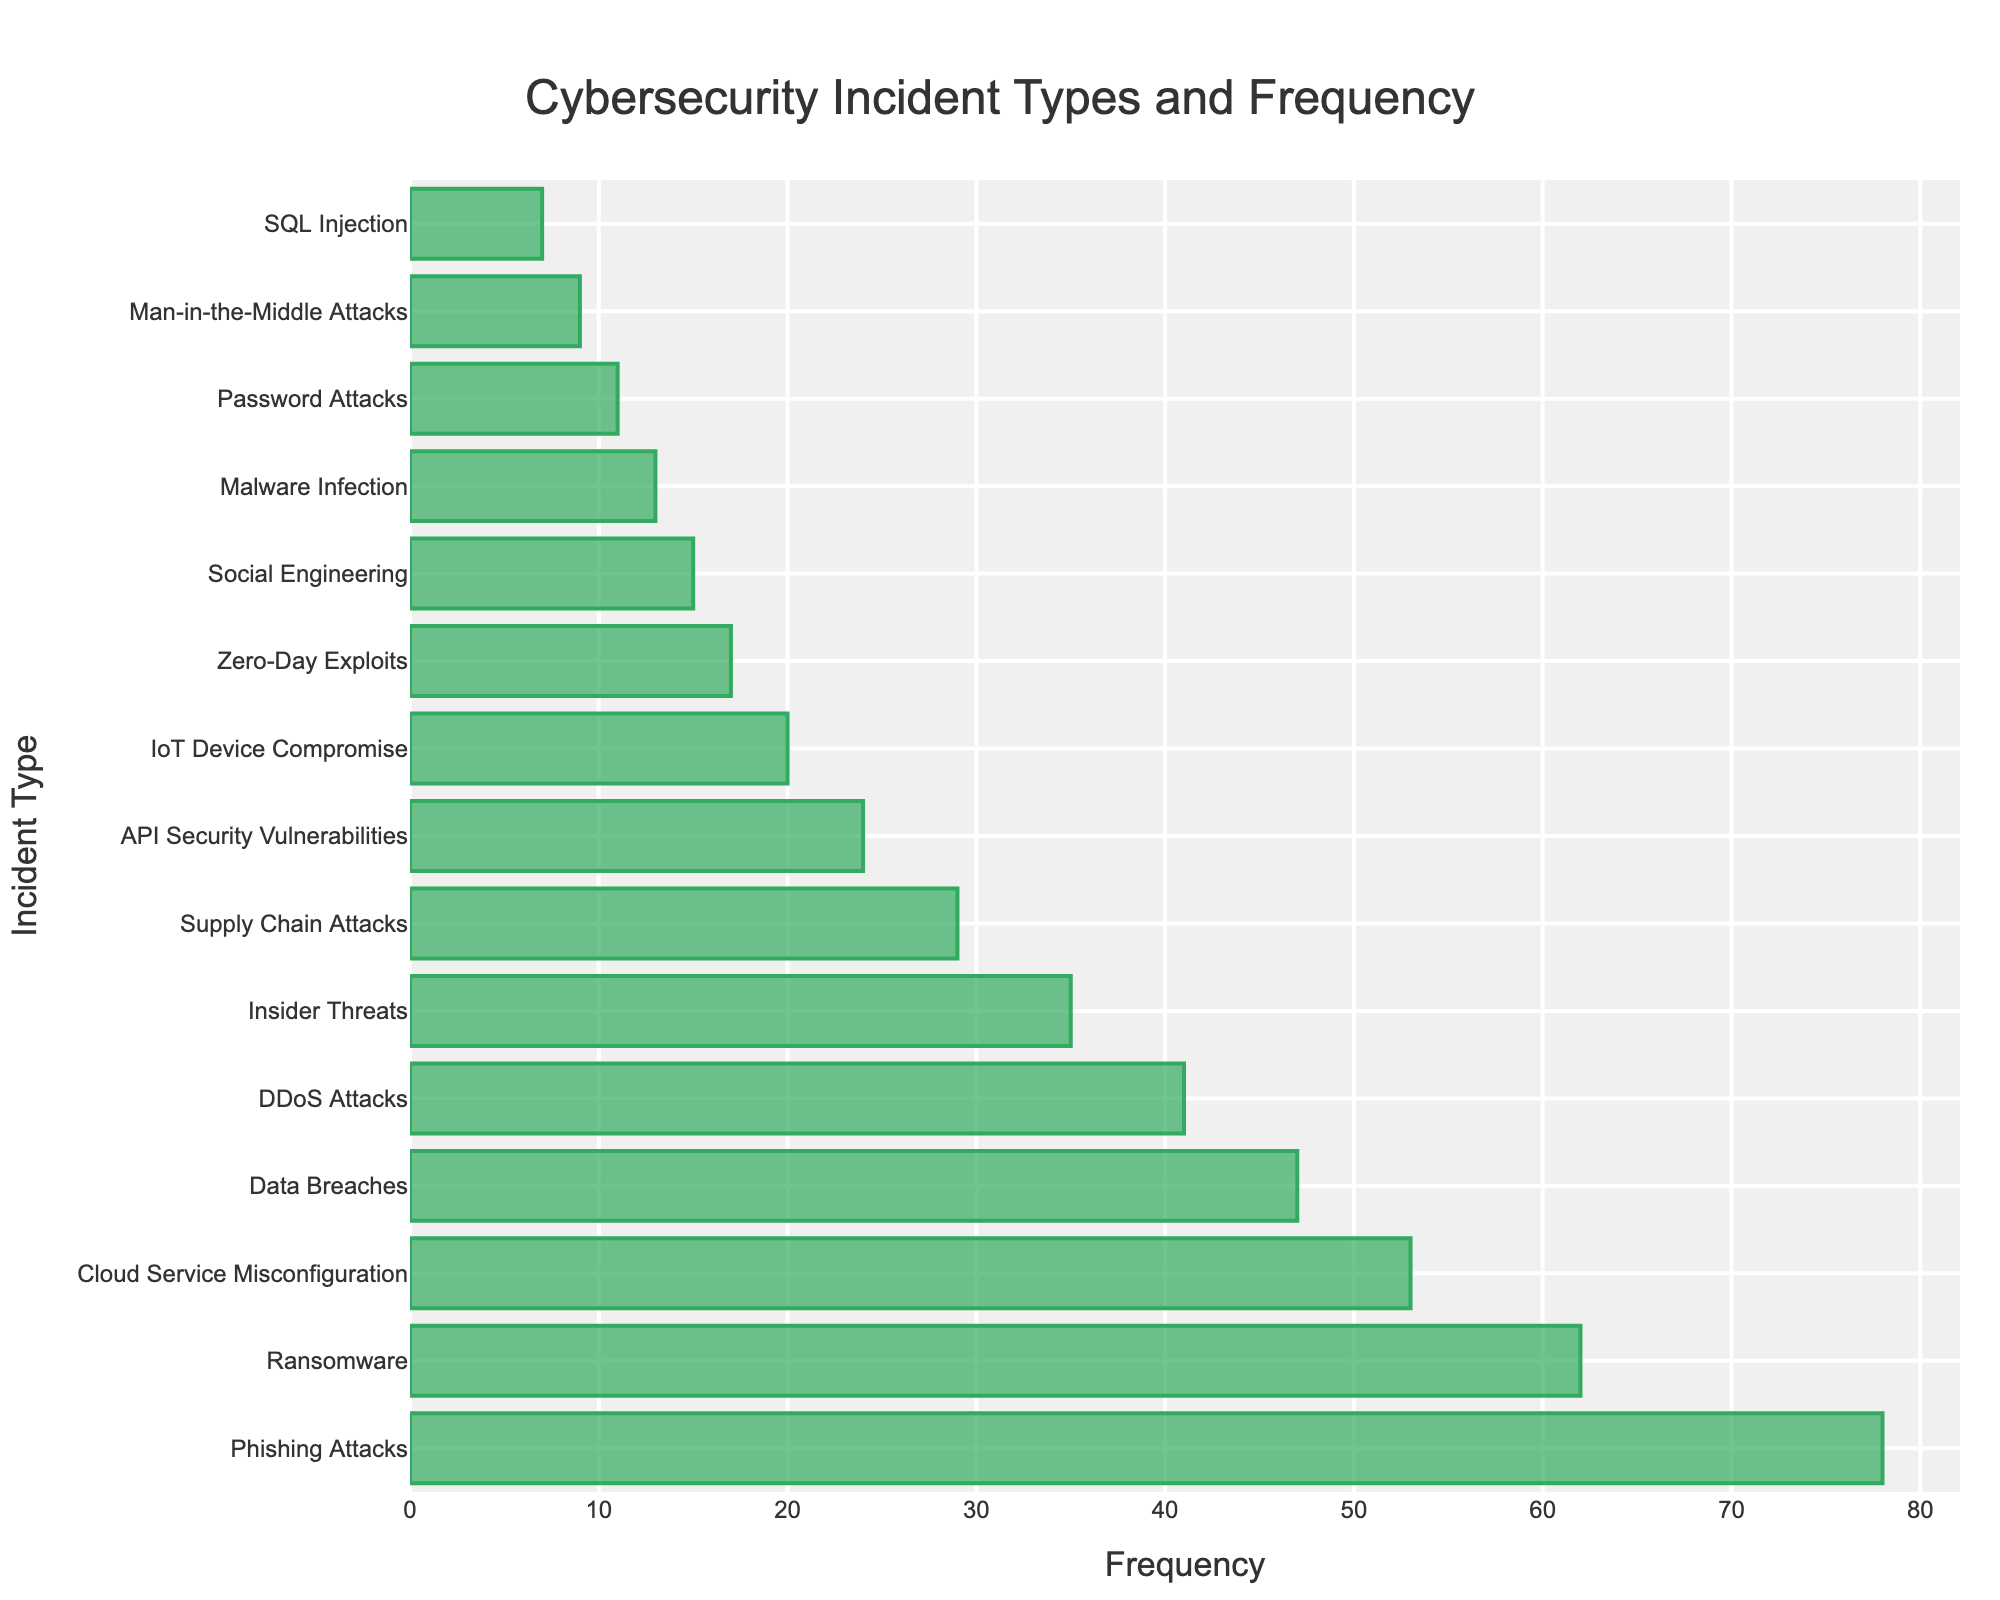What's the most frequent type of cyber incident? The bar representing Phishing Attacks is the longest, suggesting it is the most frequent incident type.
Answer: Phishing Attacks Which incident type has a frequency closest to 50? The bar for Cloud Service Misconfiguration is near the 50 mark, indicating its frequency is closest to 50.
Answer: Cloud Service Misconfiguration What is the combined frequency of DDoS Attacks and Malware Infection? Sum the frequency values of DDoS Attacks (41) and Malware Infection (13). 41 + 13 = 54.
Answer: 54 How does the frequency of Insider Threats compare to Supply Chain Attacks? The bar for Insider Threats is longer than the bar for Supply Chain Attacks, suggesting Insider Threats are more frequent.
Answer: More frequent What's the total frequency of incidents types involving insider activity? (Phishing Attacks, Insider Threats) Sum the frequency values of Phishing Attacks (78) and Insider Threats (35). 78 + 35 = 113.
Answer: 113 How many incident types have a frequency greater than 30? Count the bars that have length greater than the 30 mark: Phishing Attacks, Ransomware, Cloud Service Misconfiguration, Data Breaches, DDoS Attacks, and Insider Threats. This totals to 6.
Answer: 6 Which incident type has a frequency of less than 10, excluding SQL Injection? The bar for Man-in-the-Middle Attacks is the only one with a frequency under 10, excluding SQL Injection.
Answer: Man-in-the-Middle Attacks What's the difference in frequency between Data Breaches and IoT Device Compromise? Subtract the frequency of IoT Device Compromise (20) from Data Breaches (47). 47 - 20 = 27.
Answer: 27 Which incident type is the least frequent? The bar for SQL Injection is the shortest, indicating it is the least frequent incident type.
Answer: SQL Injection What's the average frequency of all incident types mentioned? Add up all the frequencies and divide by the number of incident types. (78 + 62 + 53 + 47 + 41 + 35 + 29 + 24 + 20 + 17 + 15 + 13 + 11 + 9 + 7) / 15 = 460 / 15 ≈ 30.67.
Answer: 30.67 